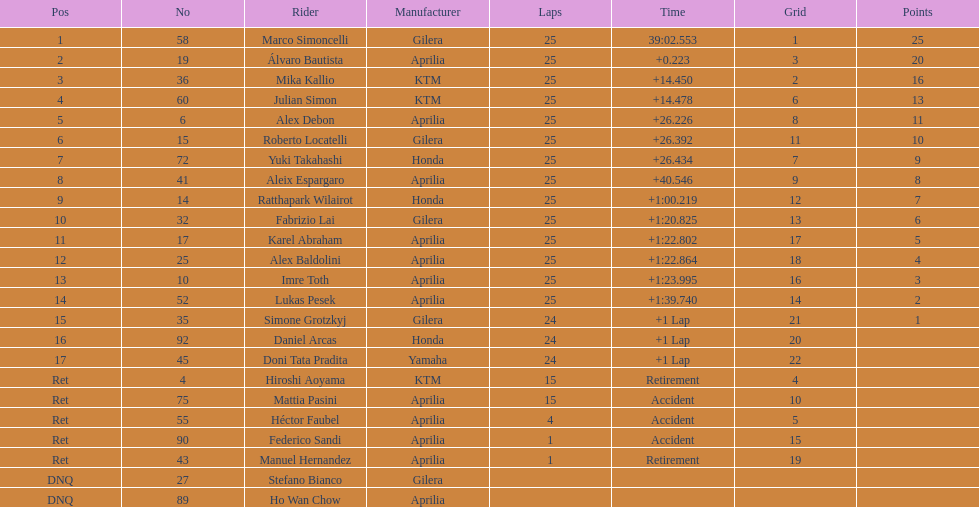How many riders were unable to qualify in total? 2. 